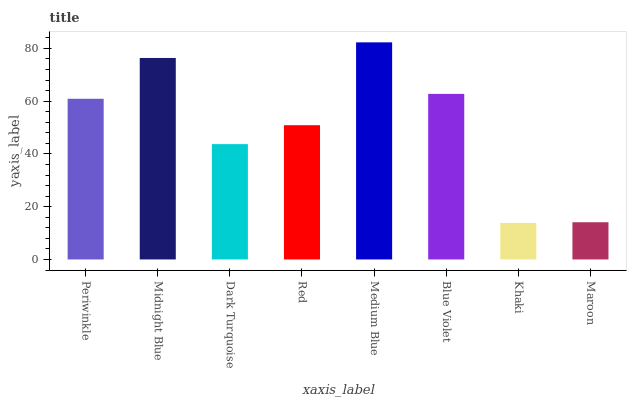Is Khaki the minimum?
Answer yes or no. Yes. Is Medium Blue the maximum?
Answer yes or no. Yes. Is Midnight Blue the minimum?
Answer yes or no. No. Is Midnight Blue the maximum?
Answer yes or no. No. Is Midnight Blue greater than Periwinkle?
Answer yes or no. Yes. Is Periwinkle less than Midnight Blue?
Answer yes or no. Yes. Is Periwinkle greater than Midnight Blue?
Answer yes or no. No. Is Midnight Blue less than Periwinkle?
Answer yes or no. No. Is Periwinkle the high median?
Answer yes or no. Yes. Is Red the low median?
Answer yes or no. Yes. Is Dark Turquoise the high median?
Answer yes or no. No. Is Maroon the low median?
Answer yes or no. No. 